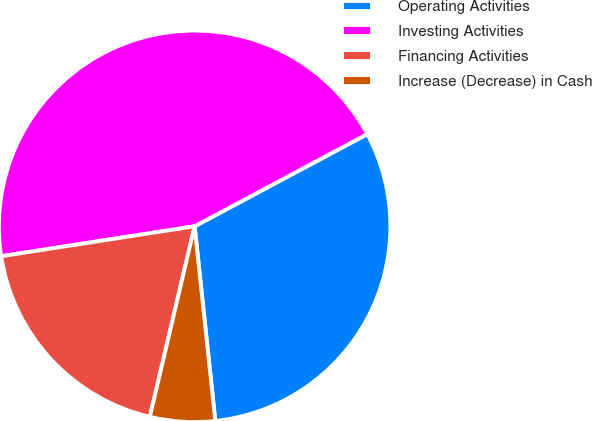Convert chart to OTSL. <chart><loc_0><loc_0><loc_500><loc_500><pie_chart><fcel>Operating Activities<fcel>Investing Activities<fcel>Financing Activities<fcel>Increase (Decrease) in Cash<nl><fcel>31.12%<fcel>44.64%<fcel>18.88%<fcel>5.36%<nl></chart> 